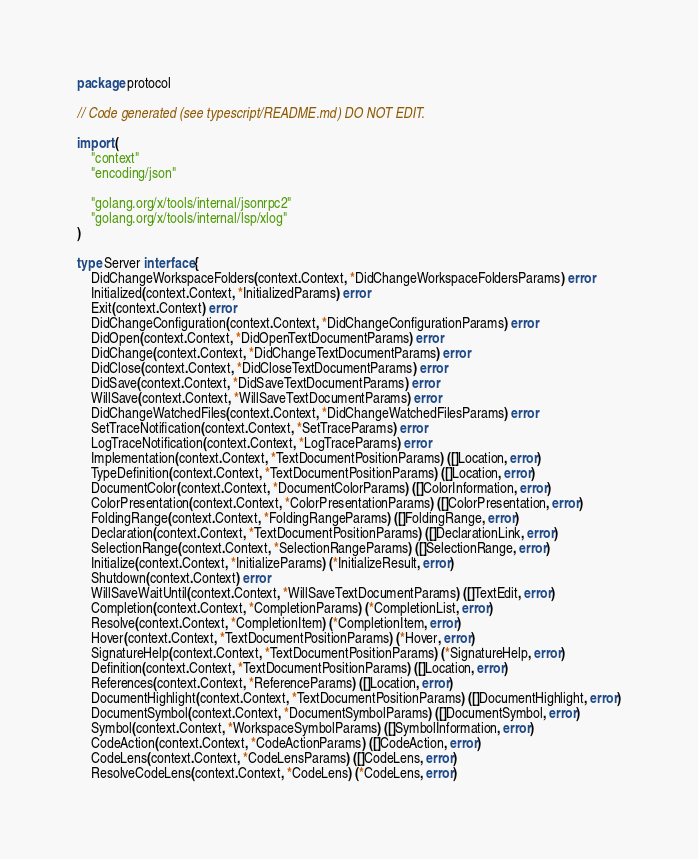<code> <loc_0><loc_0><loc_500><loc_500><_Go_>package protocol

// Code generated (see typescript/README.md) DO NOT EDIT.

import (
	"context"
	"encoding/json"

	"golang.org/x/tools/internal/jsonrpc2"
	"golang.org/x/tools/internal/lsp/xlog"
)

type Server interface {
	DidChangeWorkspaceFolders(context.Context, *DidChangeWorkspaceFoldersParams) error
	Initialized(context.Context, *InitializedParams) error
	Exit(context.Context) error
	DidChangeConfiguration(context.Context, *DidChangeConfigurationParams) error
	DidOpen(context.Context, *DidOpenTextDocumentParams) error
	DidChange(context.Context, *DidChangeTextDocumentParams) error
	DidClose(context.Context, *DidCloseTextDocumentParams) error
	DidSave(context.Context, *DidSaveTextDocumentParams) error
	WillSave(context.Context, *WillSaveTextDocumentParams) error
	DidChangeWatchedFiles(context.Context, *DidChangeWatchedFilesParams) error
	SetTraceNotification(context.Context, *SetTraceParams) error
	LogTraceNotification(context.Context, *LogTraceParams) error
	Implementation(context.Context, *TextDocumentPositionParams) ([]Location, error)
	TypeDefinition(context.Context, *TextDocumentPositionParams) ([]Location, error)
	DocumentColor(context.Context, *DocumentColorParams) ([]ColorInformation, error)
	ColorPresentation(context.Context, *ColorPresentationParams) ([]ColorPresentation, error)
	FoldingRange(context.Context, *FoldingRangeParams) ([]FoldingRange, error)
	Declaration(context.Context, *TextDocumentPositionParams) ([]DeclarationLink, error)
	SelectionRange(context.Context, *SelectionRangeParams) ([]SelectionRange, error)
	Initialize(context.Context, *InitializeParams) (*InitializeResult, error)
	Shutdown(context.Context) error
	WillSaveWaitUntil(context.Context, *WillSaveTextDocumentParams) ([]TextEdit, error)
	Completion(context.Context, *CompletionParams) (*CompletionList, error)
	Resolve(context.Context, *CompletionItem) (*CompletionItem, error)
	Hover(context.Context, *TextDocumentPositionParams) (*Hover, error)
	SignatureHelp(context.Context, *TextDocumentPositionParams) (*SignatureHelp, error)
	Definition(context.Context, *TextDocumentPositionParams) ([]Location, error)
	References(context.Context, *ReferenceParams) ([]Location, error)
	DocumentHighlight(context.Context, *TextDocumentPositionParams) ([]DocumentHighlight, error)
	DocumentSymbol(context.Context, *DocumentSymbolParams) ([]DocumentSymbol, error)
	Symbol(context.Context, *WorkspaceSymbolParams) ([]SymbolInformation, error)
	CodeAction(context.Context, *CodeActionParams) ([]CodeAction, error)
	CodeLens(context.Context, *CodeLensParams) ([]CodeLens, error)
	ResolveCodeLens(context.Context, *CodeLens) (*CodeLens, error)</code> 